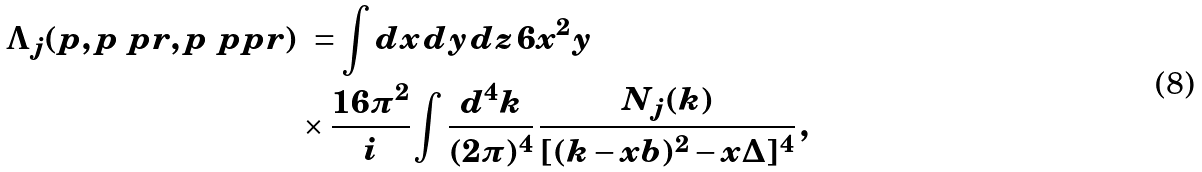Convert formula to latex. <formula><loc_0><loc_0><loc_500><loc_500>\Lambda _ { j } ( p , p \ p r , p \ p p r ) & \ = \int d x \, d y \, d z \, 6 x ^ { 2 } y \, \\ & \times \frac { 1 6 \pi ^ { 2 } } { i } \int \frac { d ^ { 4 } k } { ( 2 \pi ) ^ { 4 } } \, \frac { N _ { j } ( k ) } { [ ( k - x b ) ^ { 2 } - x \Delta ] ^ { 4 } } \, ,</formula> 